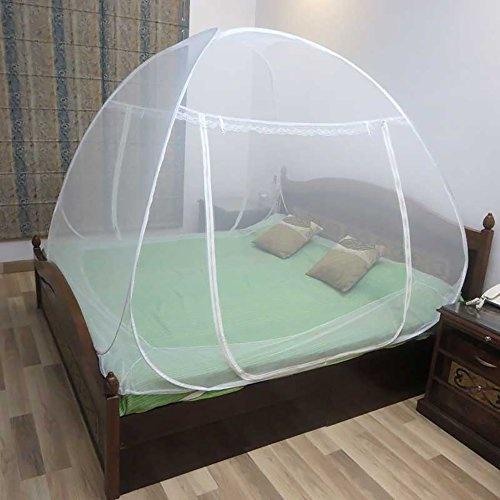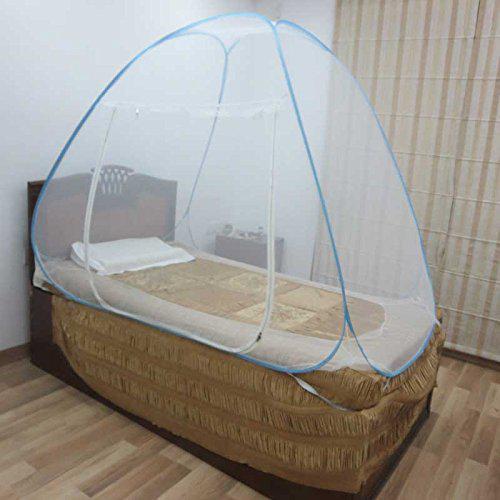The first image is the image on the left, the second image is the image on the right. For the images shown, is this caption "Each image shows a gauzy white canopy that suspends from above to surround a mattress, and at least one image shows two people lying under the canopy." true? Answer yes or no. No. 